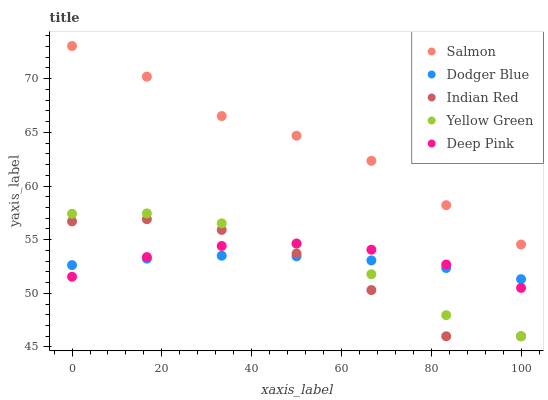Does Indian Red have the minimum area under the curve?
Answer yes or no. Yes. Does Salmon have the maximum area under the curve?
Answer yes or no. Yes. Does Deep Pink have the minimum area under the curve?
Answer yes or no. No. Does Deep Pink have the maximum area under the curve?
Answer yes or no. No. Is Dodger Blue the smoothest?
Answer yes or no. Yes. Is Indian Red the roughest?
Answer yes or no. Yes. Is Deep Pink the smoothest?
Answer yes or no. No. Is Deep Pink the roughest?
Answer yes or no. No. Does Yellow Green have the lowest value?
Answer yes or no. Yes. Does Deep Pink have the lowest value?
Answer yes or no. No. Does Salmon have the highest value?
Answer yes or no. Yes. Does Deep Pink have the highest value?
Answer yes or no. No. Is Deep Pink less than Salmon?
Answer yes or no. Yes. Is Salmon greater than Dodger Blue?
Answer yes or no. Yes. Does Yellow Green intersect Indian Red?
Answer yes or no. Yes. Is Yellow Green less than Indian Red?
Answer yes or no. No. Is Yellow Green greater than Indian Red?
Answer yes or no. No. Does Deep Pink intersect Salmon?
Answer yes or no. No. 